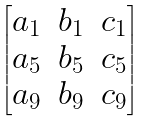<formula> <loc_0><loc_0><loc_500><loc_500>\begin{bmatrix} a _ { 1 } & b _ { 1 } & c _ { 1 } \\ a _ { 5 } & b _ { 5 } & c _ { 5 } \\ a _ { 9 } & b _ { 9 } & c _ { 9 } \end{bmatrix}</formula> 